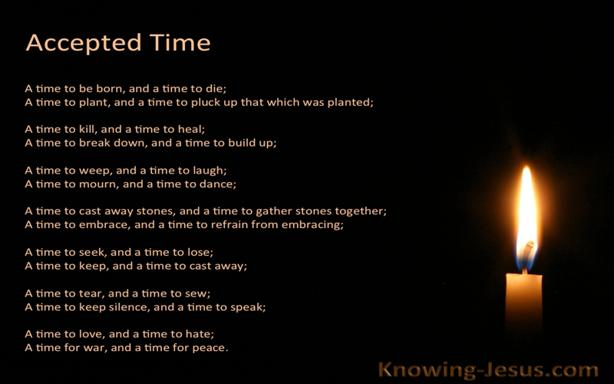How does the quote apply to modern life challenges? The quote from Ecclesiastes remains profoundly relevant today, offering a reflective perspective on life's cyclic nature. By recognizing that every moment—whether of joy, sorrow, building, or resting—has its purpose, it encourages finding balance and meaning in our modern lives, where change is constant and sometimes overwhelming. 